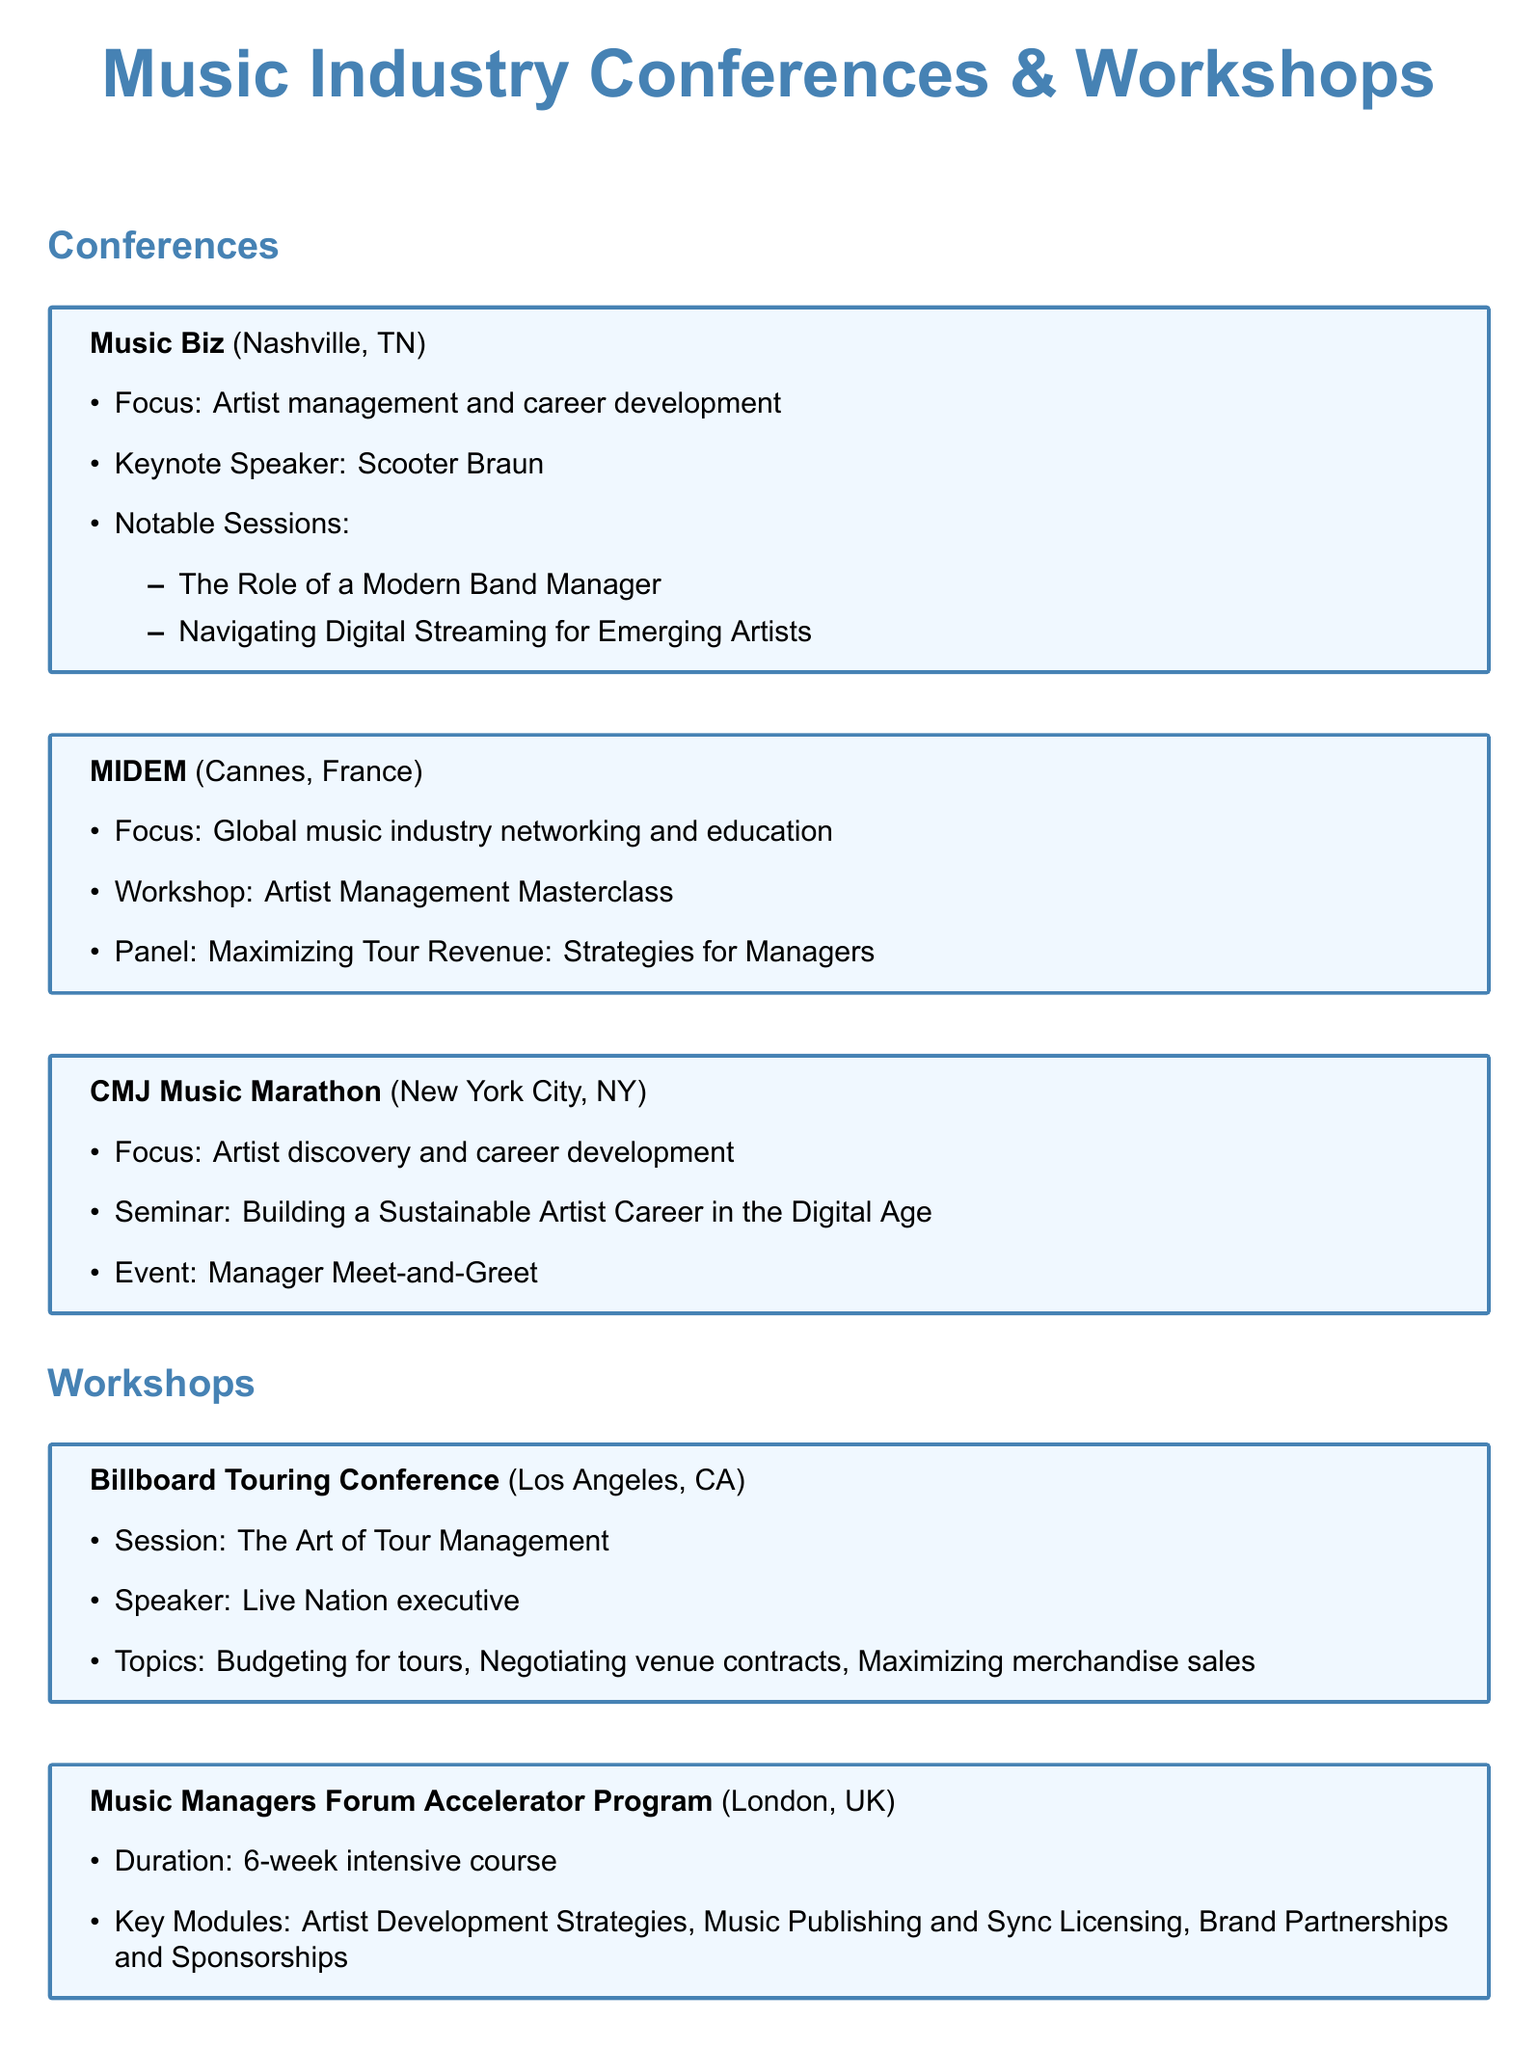What is the location of the Music Biz conference? The document states that the Music Biz conference takes place in Nashville, TN.
Answer: Nashville, TN Who is the keynote speaker at Music Biz? The document mentions that Scooter Braun is the keynote speaker at Music Biz.
Answer: Scooter Braun What is one of the notable sessions at Music Biz? The document lists "The Role of a Modern Band Manager" as a notable session at Music Biz.
Answer: The Role of a Modern Band Manager How long is the Music Managers Forum Accelerator Program? The document indicates that the program is a 6-week intensive course.
Answer: 6 weeks What focus does the CMJ Music Marathon have? The document states that the CMJ Music Marathon focuses on artist discovery and career development.
Answer: Artist discovery and career development Which workshop discusses budgeting for tours? The document states that the Billboard Touring Conference discusses budgeting for tours.
Answer: Billboard Touring Conference What is a key module in the Music Managers Forum Accelerator Program? The document lists "Artist Development Strategies" as a key module of the program.
Answer: Artist Development Strategies What is the main topic of the Berklee Online course? According to the document, the course covers artist management.
Answer: Artist management What is one of the panel topics at MIDEM? The document mentions "Maximizing Tour Revenue: Strategies for Managers" as a panel topic.
Answer: Maximizing Tour Revenue: Strategies for Managers 